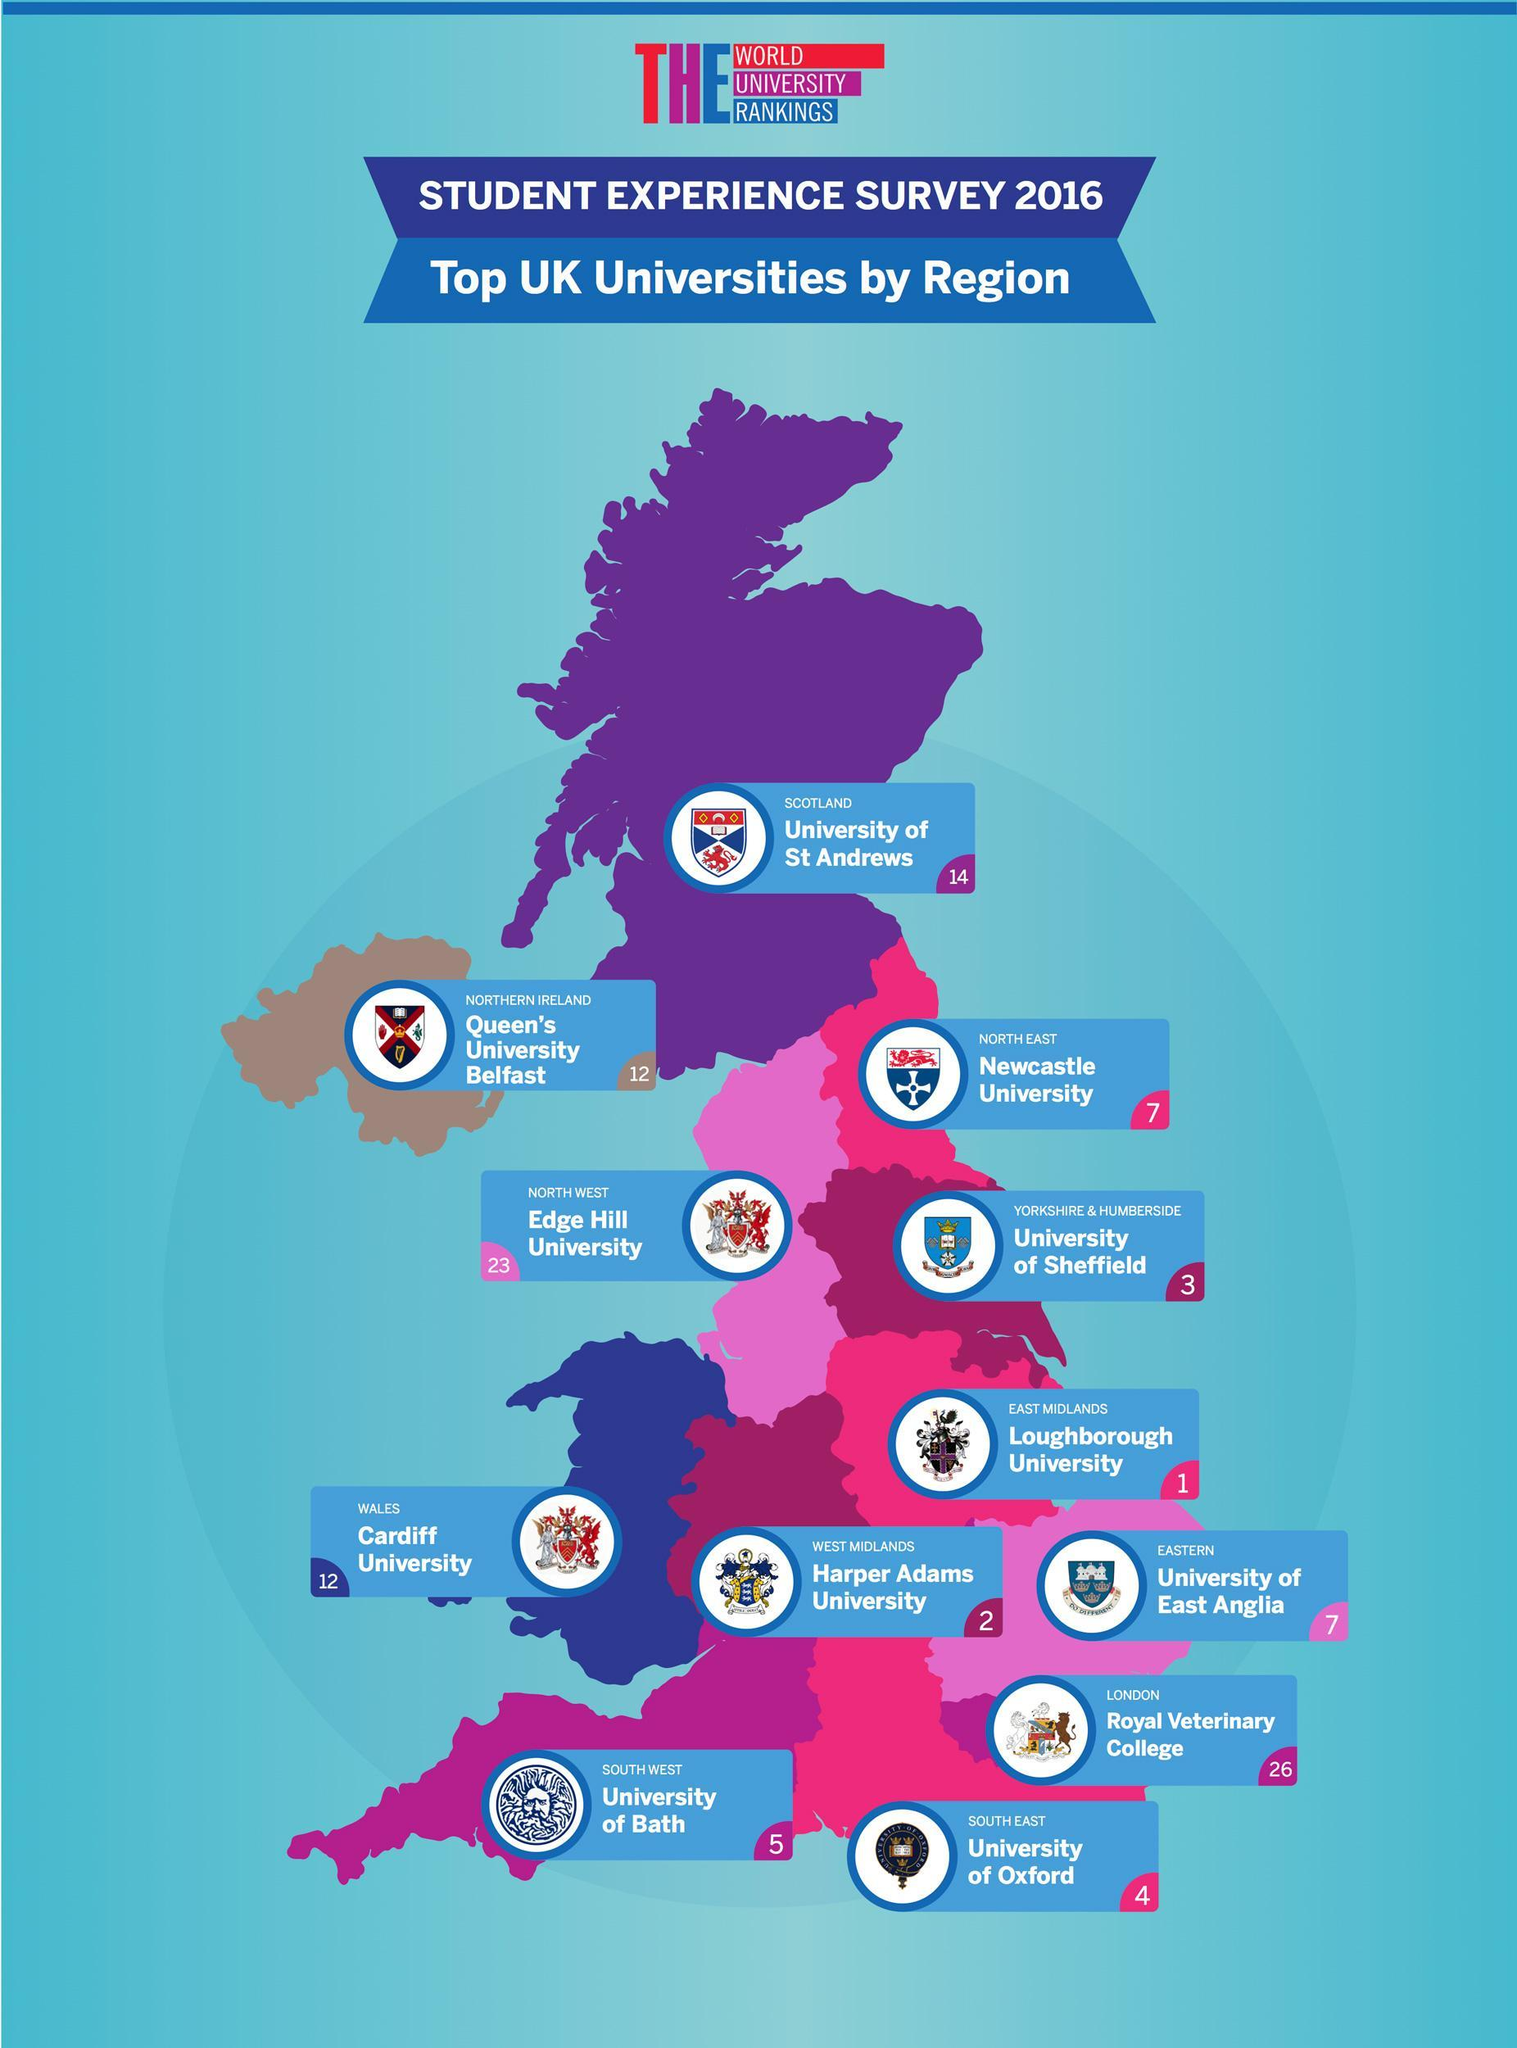Which UK university is ranked no.3 according to the student experience survey 2016?
Answer the question with a short phrase. University of Sheffield In which region of UK, the Edge Hill University is located? NORTH WEST Which UK university is ranked no.1 according to the student experience survey 2016? Loughborough University Which is the top rated university in Northern Ireland according to the student experience survey 2016? Queen's University Belfast Which is the top rated university in Wales according to the student experience survey 2016? Cardiff University In which region of UK, the University of Oxford is located? SOUTH EAST Which UK university is ranked no.2 according to the student experience survey 2016? Harper Adams University 